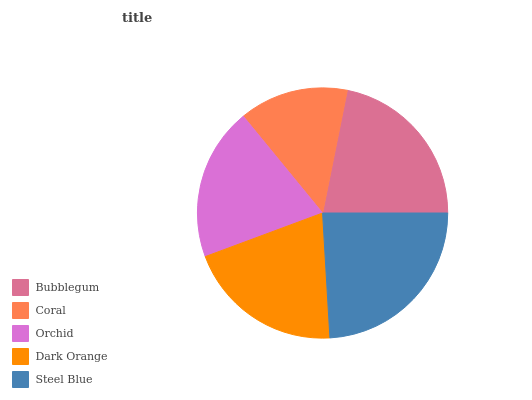Is Coral the minimum?
Answer yes or no. Yes. Is Steel Blue the maximum?
Answer yes or no. Yes. Is Orchid the minimum?
Answer yes or no. No. Is Orchid the maximum?
Answer yes or no. No. Is Orchid greater than Coral?
Answer yes or no. Yes. Is Coral less than Orchid?
Answer yes or no. Yes. Is Coral greater than Orchid?
Answer yes or no. No. Is Orchid less than Coral?
Answer yes or no. No. Is Dark Orange the high median?
Answer yes or no. Yes. Is Dark Orange the low median?
Answer yes or no. Yes. Is Orchid the high median?
Answer yes or no. No. Is Coral the low median?
Answer yes or no. No. 